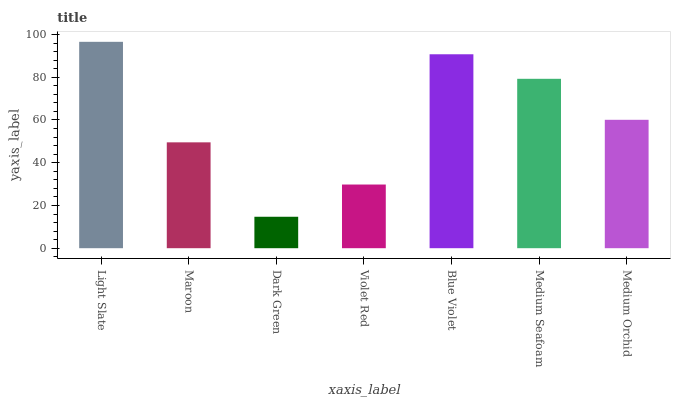Is Maroon the minimum?
Answer yes or no. No. Is Maroon the maximum?
Answer yes or no. No. Is Light Slate greater than Maroon?
Answer yes or no. Yes. Is Maroon less than Light Slate?
Answer yes or no. Yes. Is Maroon greater than Light Slate?
Answer yes or no. No. Is Light Slate less than Maroon?
Answer yes or no. No. Is Medium Orchid the high median?
Answer yes or no. Yes. Is Medium Orchid the low median?
Answer yes or no. Yes. Is Blue Violet the high median?
Answer yes or no. No. Is Dark Green the low median?
Answer yes or no. No. 